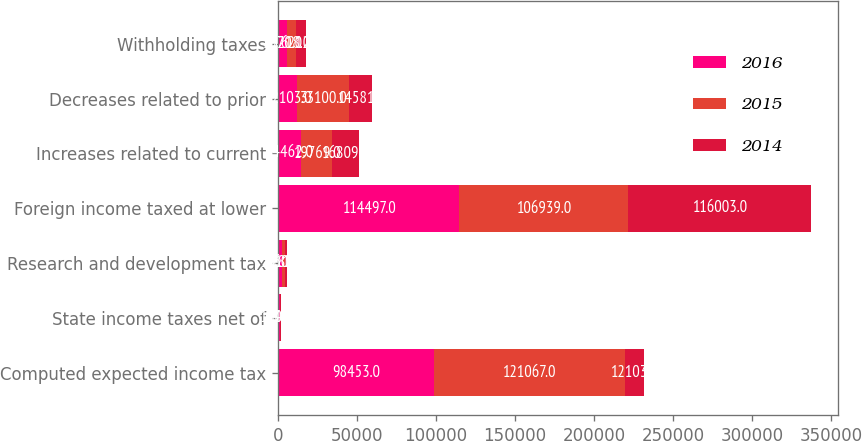Convert chart to OTSL. <chart><loc_0><loc_0><loc_500><loc_500><stacked_bar_chart><ecel><fcel>Computed expected income tax<fcel>State income taxes net of<fcel>Research and development tax<fcel>Foreign income taxed at lower<fcel>Increases related to current<fcel>Decreases related to prior<fcel>Withholding taxes<nl><fcel>2016<fcel>98453<fcel>1246<fcel>2511<fcel>114497<fcel>14462<fcel>12103<fcel>5970<nl><fcel>2015<fcel>121067<fcel>20<fcel>1789<fcel>106939<fcel>19769<fcel>33100<fcel>5218<nl><fcel>2014<fcel>12103<fcel>686<fcel>1600<fcel>116003<fcel>16809<fcel>14581<fcel>6212<nl></chart> 